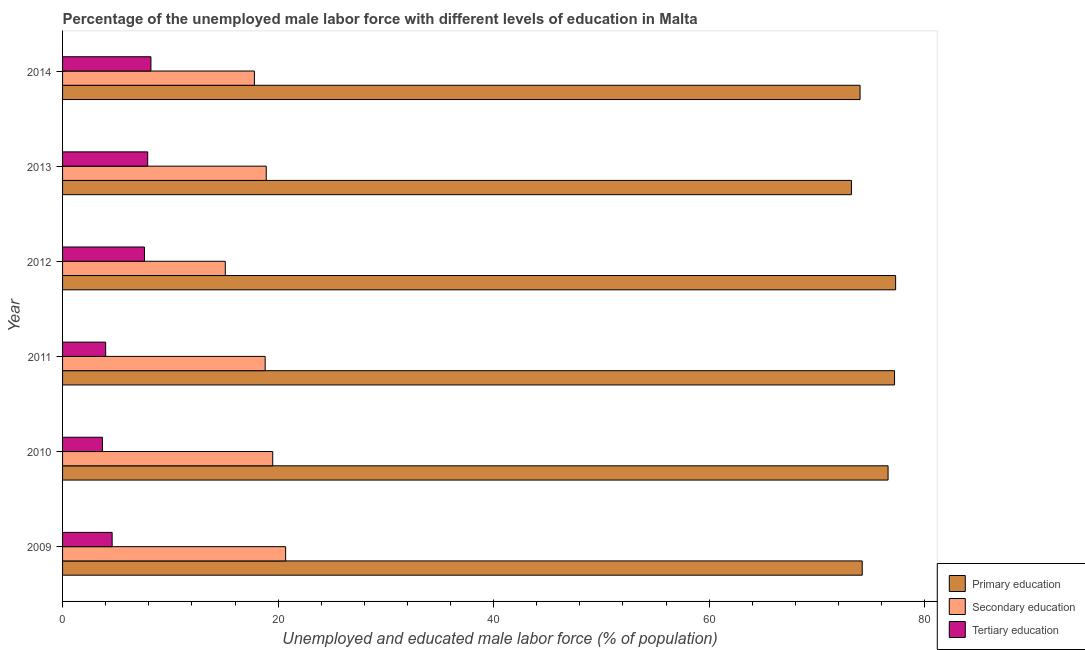How many different coloured bars are there?
Provide a succinct answer. 3. How many bars are there on the 1st tick from the top?
Provide a succinct answer. 3. Across all years, what is the maximum percentage of male labor force who received primary education?
Provide a succinct answer. 77.3. Across all years, what is the minimum percentage of male labor force who received secondary education?
Offer a terse response. 15.1. In which year was the percentage of male labor force who received secondary education minimum?
Make the answer very short. 2012. What is the total percentage of male labor force who received secondary education in the graph?
Ensure brevity in your answer.  110.8. What is the difference between the percentage of male labor force who received secondary education in 2013 and that in 2014?
Your response must be concise. 1.1. What is the difference between the percentage of male labor force who received tertiary education in 2012 and the percentage of male labor force who received primary education in 2013?
Your answer should be very brief. -65.6. What is the average percentage of male labor force who received tertiary education per year?
Offer a terse response. 6. In the year 2013, what is the difference between the percentage of male labor force who received secondary education and percentage of male labor force who received primary education?
Provide a short and direct response. -54.3. In how many years, is the percentage of male labor force who received primary education greater than 20 %?
Your answer should be compact. 6. What is the ratio of the percentage of male labor force who received tertiary education in 2012 to that in 2014?
Your answer should be very brief. 0.93. Is the percentage of male labor force who received secondary education in 2011 less than that in 2014?
Offer a terse response. No. Is the difference between the percentage of male labor force who received tertiary education in 2010 and 2013 greater than the difference between the percentage of male labor force who received secondary education in 2010 and 2013?
Offer a very short reply. No. In how many years, is the percentage of male labor force who received primary education greater than the average percentage of male labor force who received primary education taken over all years?
Your answer should be compact. 3. Is the sum of the percentage of male labor force who received secondary education in 2010 and 2011 greater than the maximum percentage of male labor force who received primary education across all years?
Provide a succinct answer. No. What does the 2nd bar from the top in 2014 represents?
Your response must be concise. Secondary education. What does the 2nd bar from the bottom in 2012 represents?
Keep it short and to the point. Secondary education. How many bars are there?
Make the answer very short. 18. Are the values on the major ticks of X-axis written in scientific E-notation?
Ensure brevity in your answer.  No. Where does the legend appear in the graph?
Give a very brief answer. Bottom right. How many legend labels are there?
Ensure brevity in your answer.  3. What is the title of the graph?
Offer a terse response. Percentage of the unemployed male labor force with different levels of education in Malta. Does "Ages 0-14" appear as one of the legend labels in the graph?
Make the answer very short. No. What is the label or title of the X-axis?
Give a very brief answer. Unemployed and educated male labor force (% of population). What is the label or title of the Y-axis?
Offer a terse response. Year. What is the Unemployed and educated male labor force (% of population) of Primary education in 2009?
Your answer should be very brief. 74.2. What is the Unemployed and educated male labor force (% of population) in Secondary education in 2009?
Give a very brief answer. 20.7. What is the Unemployed and educated male labor force (% of population) of Tertiary education in 2009?
Provide a succinct answer. 4.6. What is the Unemployed and educated male labor force (% of population) in Primary education in 2010?
Provide a succinct answer. 76.6. What is the Unemployed and educated male labor force (% of population) of Secondary education in 2010?
Ensure brevity in your answer.  19.5. What is the Unemployed and educated male labor force (% of population) of Tertiary education in 2010?
Offer a terse response. 3.7. What is the Unemployed and educated male labor force (% of population) of Primary education in 2011?
Your response must be concise. 77.2. What is the Unemployed and educated male labor force (% of population) in Secondary education in 2011?
Your response must be concise. 18.8. What is the Unemployed and educated male labor force (% of population) in Tertiary education in 2011?
Provide a succinct answer. 4. What is the Unemployed and educated male labor force (% of population) of Primary education in 2012?
Your answer should be very brief. 77.3. What is the Unemployed and educated male labor force (% of population) in Secondary education in 2012?
Your answer should be compact. 15.1. What is the Unemployed and educated male labor force (% of population) of Tertiary education in 2012?
Ensure brevity in your answer.  7.6. What is the Unemployed and educated male labor force (% of population) of Primary education in 2013?
Offer a terse response. 73.2. What is the Unemployed and educated male labor force (% of population) of Secondary education in 2013?
Provide a short and direct response. 18.9. What is the Unemployed and educated male labor force (% of population) in Tertiary education in 2013?
Offer a very short reply. 7.9. What is the Unemployed and educated male labor force (% of population) of Primary education in 2014?
Provide a short and direct response. 74. What is the Unemployed and educated male labor force (% of population) in Secondary education in 2014?
Your response must be concise. 17.8. What is the Unemployed and educated male labor force (% of population) of Tertiary education in 2014?
Your answer should be compact. 8.2. Across all years, what is the maximum Unemployed and educated male labor force (% of population) of Primary education?
Make the answer very short. 77.3. Across all years, what is the maximum Unemployed and educated male labor force (% of population) of Secondary education?
Make the answer very short. 20.7. Across all years, what is the maximum Unemployed and educated male labor force (% of population) of Tertiary education?
Provide a short and direct response. 8.2. Across all years, what is the minimum Unemployed and educated male labor force (% of population) in Primary education?
Give a very brief answer. 73.2. Across all years, what is the minimum Unemployed and educated male labor force (% of population) in Secondary education?
Provide a short and direct response. 15.1. Across all years, what is the minimum Unemployed and educated male labor force (% of population) in Tertiary education?
Provide a succinct answer. 3.7. What is the total Unemployed and educated male labor force (% of population) of Primary education in the graph?
Your answer should be very brief. 452.5. What is the total Unemployed and educated male labor force (% of population) of Secondary education in the graph?
Offer a very short reply. 110.8. What is the difference between the Unemployed and educated male labor force (% of population) of Primary education in 2009 and that in 2010?
Offer a very short reply. -2.4. What is the difference between the Unemployed and educated male labor force (% of population) in Tertiary education in 2009 and that in 2010?
Keep it short and to the point. 0.9. What is the difference between the Unemployed and educated male labor force (% of population) in Primary education in 2009 and that in 2011?
Your answer should be compact. -3. What is the difference between the Unemployed and educated male labor force (% of population) in Primary education in 2009 and that in 2012?
Provide a succinct answer. -3.1. What is the difference between the Unemployed and educated male labor force (% of population) of Tertiary education in 2009 and that in 2012?
Your answer should be very brief. -3. What is the difference between the Unemployed and educated male labor force (% of population) of Primary education in 2009 and that in 2013?
Provide a short and direct response. 1. What is the difference between the Unemployed and educated male labor force (% of population) in Tertiary education in 2009 and that in 2014?
Keep it short and to the point. -3.6. What is the difference between the Unemployed and educated male labor force (% of population) of Primary education in 2010 and that in 2011?
Your response must be concise. -0.6. What is the difference between the Unemployed and educated male labor force (% of population) of Tertiary education in 2010 and that in 2011?
Your response must be concise. -0.3. What is the difference between the Unemployed and educated male labor force (% of population) of Tertiary education in 2010 and that in 2013?
Make the answer very short. -4.2. What is the difference between the Unemployed and educated male labor force (% of population) of Primary education in 2011 and that in 2012?
Give a very brief answer. -0.1. What is the difference between the Unemployed and educated male labor force (% of population) of Tertiary education in 2011 and that in 2012?
Your answer should be very brief. -3.6. What is the difference between the Unemployed and educated male labor force (% of population) in Secondary education in 2011 and that in 2013?
Offer a very short reply. -0.1. What is the difference between the Unemployed and educated male labor force (% of population) in Tertiary education in 2011 and that in 2013?
Give a very brief answer. -3.9. What is the difference between the Unemployed and educated male labor force (% of population) in Tertiary education in 2011 and that in 2014?
Keep it short and to the point. -4.2. What is the difference between the Unemployed and educated male labor force (% of population) of Tertiary education in 2012 and that in 2013?
Make the answer very short. -0.3. What is the difference between the Unemployed and educated male labor force (% of population) of Secondary education in 2012 and that in 2014?
Ensure brevity in your answer.  -2.7. What is the difference between the Unemployed and educated male labor force (% of population) in Primary education in 2009 and the Unemployed and educated male labor force (% of population) in Secondary education in 2010?
Offer a terse response. 54.7. What is the difference between the Unemployed and educated male labor force (% of population) in Primary education in 2009 and the Unemployed and educated male labor force (% of population) in Tertiary education in 2010?
Provide a short and direct response. 70.5. What is the difference between the Unemployed and educated male labor force (% of population) of Secondary education in 2009 and the Unemployed and educated male labor force (% of population) of Tertiary education in 2010?
Make the answer very short. 17. What is the difference between the Unemployed and educated male labor force (% of population) in Primary education in 2009 and the Unemployed and educated male labor force (% of population) in Secondary education in 2011?
Keep it short and to the point. 55.4. What is the difference between the Unemployed and educated male labor force (% of population) in Primary education in 2009 and the Unemployed and educated male labor force (% of population) in Tertiary education in 2011?
Give a very brief answer. 70.2. What is the difference between the Unemployed and educated male labor force (% of population) in Secondary education in 2009 and the Unemployed and educated male labor force (% of population) in Tertiary education in 2011?
Offer a terse response. 16.7. What is the difference between the Unemployed and educated male labor force (% of population) in Primary education in 2009 and the Unemployed and educated male labor force (% of population) in Secondary education in 2012?
Keep it short and to the point. 59.1. What is the difference between the Unemployed and educated male labor force (% of population) in Primary education in 2009 and the Unemployed and educated male labor force (% of population) in Tertiary education in 2012?
Give a very brief answer. 66.6. What is the difference between the Unemployed and educated male labor force (% of population) of Secondary education in 2009 and the Unemployed and educated male labor force (% of population) of Tertiary education in 2012?
Give a very brief answer. 13.1. What is the difference between the Unemployed and educated male labor force (% of population) in Primary education in 2009 and the Unemployed and educated male labor force (% of population) in Secondary education in 2013?
Give a very brief answer. 55.3. What is the difference between the Unemployed and educated male labor force (% of population) of Primary education in 2009 and the Unemployed and educated male labor force (% of population) of Tertiary education in 2013?
Your answer should be compact. 66.3. What is the difference between the Unemployed and educated male labor force (% of population) in Secondary education in 2009 and the Unemployed and educated male labor force (% of population) in Tertiary education in 2013?
Provide a succinct answer. 12.8. What is the difference between the Unemployed and educated male labor force (% of population) of Primary education in 2009 and the Unemployed and educated male labor force (% of population) of Secondary education in 2014?
Provide a short and direct response. 56.4. What is the difference between the Unemployed and educated male labor force (% of population) in Primary education in 2009 and the Unemployed and educated male labor force (% of population) in Tertiary education in 2014?
Make the answer very short. 66. What is the difference between the Unemployed and educated male labor force (% of population) in Primary education in 2010 and the Unemployed and educated male labor force (% of population) in Secondary education in 2011?
Provide a succinct answer. 57.8. What is the difference between the Unemployed and educated male labor force (% of population) of Primary education in 2010 and the Unemployed and educated male labor force (% of population) of Tertiary education in 2011?
Offer a terse response. 72.6. What is the difference between the Unemployed and educated male labor force (% of population) of Secondary education in 2010 and the Unemployed and educated male labor force (% of population) of Tertiary education in 2011?
Offer a very short reply. 15.5. What is the difference between the Unemployed and educated male labor force (% of population) of Primary education in 2010 and the Unemployed and educated male labor force (% of population) of Secondary education in 2012?
Ensure brevity in your answer.  61.5. What is the difference between the Unemployed and educated male labor force (% of population) in Primary education in 2010 and the Unemployed and educated male labor force (% of population) in Tertiary education in 2012?
Give a very brief answer. 69. What is the difference between the Unemployed and educated male labor force (% of population) of Primary education in 2010 and the Unemployed and educated male labor force (% of population) of Secondary education in 2013?
Keep it short and to the point. 57.7. What is the difference between the Unemployed and educated male labor force (% of population) of Primary education in 2010 and the Unemployed and educated male labor force (% of population) of Tertiary education in 2013?
Offer a terse response. 68.7. What is the difference between the Unemployed and educated male labor force (% of population) of Primary education in 2010 and the Unemployed and educated male labor force (% of population) of Secondary education in 2014?
Your answer should be very brief. 58.8. What is the difference between the Unemployed and educated male labor force (% of population) in Primary education in 2010 and the Unemployed and educated male labor force (% of population) in Tertiary education in 2014?
Ensure brevity in your answer.  68.4. What is the difference between the Unemployed and educated male labor force (% of population) of Secondary education in 2010 and the Unemployed and educated male labor force (% of population) of Tertiary education in 2014?
Give a very brief answer. 11.3. What is the difference between the Unemployed and educated male labor force (% of population) in Primary education in 2011 and the Unemployed and educated male labor force (% of population) in Secondary education in 2012?
Offer a very short reply. 62.1. What is the difference between the Unemployed and educated male labor force (% of population) of Primary education in 2011 and the Unemployed and educated male labor force (% of population) of Tertiary education in 2012?
Your response must be concise. 69.6. What is the difference between the Unemployed and educated male labor force (% of population) of Primary education in 2011 and the Unemployed and educated male labor force (% of population) of Secondary education in 2013?
Offer a terse response. 58.3. What is the difference between the Unemployed and educated male labor force (% of population) of Primary education in 2011 and the Unemployed and educated male labor force (% of population) of Tertiary education in 2013?
Make the answer very short. 69.3. What is the difference between the Unemployed and educated male labor force (% of population) of Secondary education in 2011 and the Unemployed and educated male labor force (% of population) of Tertiary education in 2013?
Your response must be concise. 10.9. What is the difference between the Unemployed and educated male labor force (% of population) of Primary education in 2011 and the Unemployed and educated male labor force (% of population) of Secondary education in 2014?
Your response must be concise. 59.4. What is the difference between the Unemployed and educated male labor force (% of population) in Primary education in 2012 and the Unemployed and educated male labor force (% of population) in Secondary education in 2013?
Your response must be concise. 58.4. What is the difference between the Unemployed and educated male labor force (% of population) of Primary education in 2012 and the Unemployed and educated male labor force (% of population) of Tertiary education in 2013?
Your response must be concise. 69.4. What is the difference between the Unemployed and educated male labor force (% of population) of Primary education in 2012 and the Unemployed and educated male labor force (% of population) of Secondary education in 2014?
Your answer should be very brief. 59.5. What is the difference between the Unemployed and educated male labor force (% of population) of Primary education in 2012 and the Unemployed and educated male labor force (% of population) of Tertiary education in 2014?
Ensure brevity in your answer.  69.1. What is the difference between the Unemployed and educated male labor force (% of population) in Secondary education in 2012 and the Unemployed and educated male labor force (% of population) in Tertiary education in 2014?
Give a very brief answer. 6.9. What is the difference between the Unemployed and educated male labor force (% of population) in Primary education in 2013 and the Unemployed and educated male labor force (% of population) in Secondary education in 2014?
Offer a very short reply. 55.4. What is the difference between the Unemployed and educated male labor force (% of population) of Secondary education in 2013 and the Unemployed and educated male labor force (% of population) of Tertiary education in 2014?
Ensure brevity in your answer.  10.7. What is the average Unemployed and educated male labor force (% of population) in Primary education per year?
Give a very brief answer. 75.42. What is the average Unemployed and educated male labor force (% of population) of Secondary education per year?
Your answer should be very brief. 18.47. What is the average Unemployed and educated male labor force (% of population) of Tertiary education per year?
Your answer should be very brief. 6. In the year 2009, what is the difference between the Unemployed and educated male labor force (% of population) in Primary education and Unemployed and educated male labor force (% of population) in Secondary education?
Give a very brief answer. 53.5. In the year 2009, what is the difference between the Unemployed and educated male labor force (% of population) in Primary education and Unemployed and educated male labor force (% of population) in Tertiary education?
Offer a very short reply. 69.6. In the year 2010, what is the difference between the Unemployed and educated male labor force (% of population) of Primary education and Unemployed and educated male labor force (% of population) of Secondary education?
Your answer should be very brief. 57.1. In the year 2010, what is the difference between the Unemployed and educated male labor force (% of population) in Primary education and Unemployed and educated male labor force (% of population) in Tertiary education?
Make the answer very short. 72.9. In the year 2010, what is the difference between the Unemployed and educated male labor force (% of population) of Secondary education and Unemployed and educated male labor force (% of population) of Tertiary education?
Provide a succinct answer. 15.8. In the year 2011, what is the difference between the Unemployed and educated male labor force (% of population) in Primary education and Unemployed and educated male labor force (% of population) in Secondary education?
Offer a terse response. 58.4. In the year 2011, what is the difference between the Unemployed and educated male labor force (% of population) in Primary education and Unemployed and educated male labor force (% of population) in Tertiary education?
Ensure brevity in your answer.  73.2. In the year 2011, what is the difference between the Unemployed and educated male labor force (% of population) of Secondary education and Unemployed and educated male labor force (% of population) of Tertiary education?
Offer a terse response. 14.8. In the year 2012, what is the difference between the Unemployed and educated male labor force (% of population) of Primary education and Unemployed and educated male labor force (% of population) of Secondary education?
Your answer should be compact. 62.2. In the year 2012, what is the difference between the Unemployed and educated male labor force (% of population) of Primary education and Unemployed and educated male labor force (% of population) of Tertiary education?
Keep it short and to the point. 69.7. In the year 2012, what is the difference between the Unemployed and educated male labor force (% of population) in Secondary education and Unemployed and educated male labor force (% of population) in Tertiary education?
Ensure brevity in your answer.  7.5. In the year 2013, what is the difference between the Unemployed and educated male labor force (% of population) in Primary education and Unemployed and educated male labor force (% of population) in Secondary education?
Offer a terse response. 54.3. In the year 2013, what is the difference between the Unemployed and educated male labor force (% of population) of Primary education and Unemployed and educated male labor force (% of population) of Tertiary education?
Provide a short and direct response. 65.3. In the year 2014, what is the difference between the Unemployed and educated male labor force (% of population) of Primary education and Unemployed and educated male labor force (% of population) of Secondary education?
Make the answer very short. 56.2. In the year 2014, what is the difference between the Unemployed and educated male labor force (% of population) of Primary education and Unemployed and educated male labor force (% of population) of Tertiary education?
Give a very brief answer. 65.8. In the year 2014, what is the difference between the Unemployed and educated male labor force (% of population) of Secondary education and Unemployed and educated male labor force (% of population) of Tertiary education?
Your answer should be compact. 9.6. What is the ratio of the Unemployed and educated male labor force (% of population) of Primary education in 2009 to that in 2010?
Offer a very short reply. 0.97. What is the ratio of the Unemployed and educated male labor force (% of population) in Secondary education in 2009 to that in 2010?
Make the answer very short. 1.06. What is the ratio of the Unemployed and educated male labor force (% of population) of Tertiary education in 2009 to that in 2010?
Give a very brief answer. 1.24. What is the ratio of the Unemployed and educated male labor force (% of population) in Primary education in 2009 to that in 2011?
Keep it short and to the point. 0.96. What is the ratio of the Unemployed and educated male labor force (% of population) of Secondary education in 2009 to that in 2011?
Your response must be concise. 1.1. What is the ratio of the Unemployed and educated male labor force (% of population) of Tertiary education in 2009 to that in 2011?
Provide a succinct answer. 1.15. What is the ratio of the Unemployed and educated male labor force (% of population) of Primary education in 2009 to that in 2012?
Provide a succinct answer. 0.96. What is the ratio of the Unemployed and educated male labor force (% of population) in Secondary education in 2009 to that in 2012?
Your answer should be compact. 1.37. What is the ratio of the Unemployed and educated male labor force (% of population) of Tertiary education in 2009 to that in 2012?
Keep it short and to the point. 0.61. What is the ratio of the Unemployed and educated male labor force (% of population) of Primary education in 2009 to that in 2013?
Your response must be concise. 1.01. What is the ratio of the Unemployed and educated male labor force (% of population) in Secondary education in 2009 to that in 2013?
Provide a succinct answer. 1.1. What is the ratio of the Unemployed and educated male labor force (% of population) of Tertiary education in 2009 to that in 2013?
Offer a very short reply. 0.58. What is the ratio of the Unemployed and educated male labor force (% of population) of Primary education in 2009 to that in 2014?
Offer a terse response. 1. What is the ratio of the Unemployed and educated male labor force (% of population) in Secondary education in 2009 to that in 2014?
Keep it short and to the point. 1.16. What is the ratio of the Unemployed and educated male labor force (% of population) of Tertiary education in 2009 to that in 2014?
Your answer should be compact. 0.56. What is the ratio of the Unemployed and educated male labor force (% of population) in Primary education in 2010 to that in 2011?
Make the answer very short. 0.99. What is the ratio of the Unemployed and educated male labor force (% of population) of Secondary education in 2010 to that in 2011?
Make the answer very short. 1.04. What is the ratio of the Unemployed and educated male labor force (% of population) of Tertiary education in 2010 to that in 2011?
Your answer should be compact. 0.93. What is the ratio of the Unemployed and educated male labor force (% of population) in Primary education in 2010 to that in 2012?
Make the answer very short. 0.99. What is the ratio of the Unemployed and educated male labor force (% of population) in Secondary education in 2010 to that in 2012?
Your answer should be very brief. 1.29. What is the ratio of the Unemployed and educated male labor force (% of population) in Tertiary education in 2010 to that in 2012?
Offer a terse response. 0.49. What is the ratio of the Unemployed and educated male labor force (% of population) in Primary education in 2010 to that in 2013?
Ensure brevity in your answer.  1.05. What is the ratio of the Unemployed and educated male labor force (% of population) in Secondary education in 2010 to that in 2013?
Ensure brevity in your answer.  1.03. What is the ratio of the Unemployed and educated male labor force (% of population) of Tertiary education in 2010 to that in 2013?
Keep it short and to the point. 0.47. What is the ratio of the Unemployed and educated male labor force (% of population) of Primary education in 2010 to that in 2014?
Your answer should be compact. 1.04. What is the ratio of the Unemployed and educated male labor force (% of population) of Secondary education in 2010 to that in 2014?
Offer a very short reply. 1.1. What is the ratio of the Unemployed and educated male labor force (% of population) of Tertiary education in 2010 to that in 2014?
Your answer should be very brief. 0.45. What is the ratio of the Unemployed and educated male labor force (% of population) in Secondary education in 2011 to that in 2012?
Your answer should be compact. 1.25. What is the ratio of the Unemployed and educated male labor force (% of population) in Tertiary education in 2011 to that in 2012?
Your answer should be very brief. 0.53. What is the ratio of the Unemployed and educated male labor force (% of population) in Primary education in 2011 to that in 2013?
Offer a terse response. 1.05. What is the ratio of the Unemployed and educated male labor force (% of population) in Secondary education in 2011 to that in 2013?
Offer a very short reply. 0.99. What is the ratio of the Unemployed and educated male labor force (% of population) in Tertiary education in 2011 to that in 2013?
Keep it short and to the point. 0.51. What is the ratio of the Unemployed and educated male labor force (% of population) of Primary education in 2011 to that in 2014?
Provide a succinct answer. 1.04. What is the ratio of the Unemployed and educated male labor force (% of population) of Secondary education in 2011 to that in 2014?
Make the answer very short. 1.06. What is the ratio of the Unemployed and educated male labor force (% of population) of Tertiary education in 2011 to that in 2014?
Make the answer very short. 0.49. What is the ratio of the Unemployed and educated male labor force (% of population) in Primary education in 2012 to that in 2013?
Ensure brevity in your answer.  1.06. What is the ratio of the Unemployed and educated male labor force (% of population) in Secondary education in 2012 to that in 2013?
Make the answer very short. 0.8. What is the ratio of the Unemployed and educated male labor force (% of population) of Tertiary education in 2012 to that in 2013?
Provide a short and direct response. 0.96. What is the ratio of the Unemployed and educated male labor force (% of population) in Primary education in 2012 to that in 2014?
Your answer should be compact. 1.04. What is the ratio of the Unemployed and educated male labor force (% of population) in Secondary education in 2012 to that in 2014?
Offer a very short reply. 0.85. What is the ratio of the Unemployed and educated male labor force (% of population) of Tertiary education in 2012 to that in 2014?
Offer a terse response. 0.93. What is the ratio of the Unemployed and educated male labor force (% of population) of Secondary education in 2013 to that in 2014?
Ensure brevity in your answer.  1.06. What is the ratio of the Unemployed and educated male labor force (% of population) in Tertiary education in 2013 to that in 2014?
Your answer should be very brief. 0.96. 